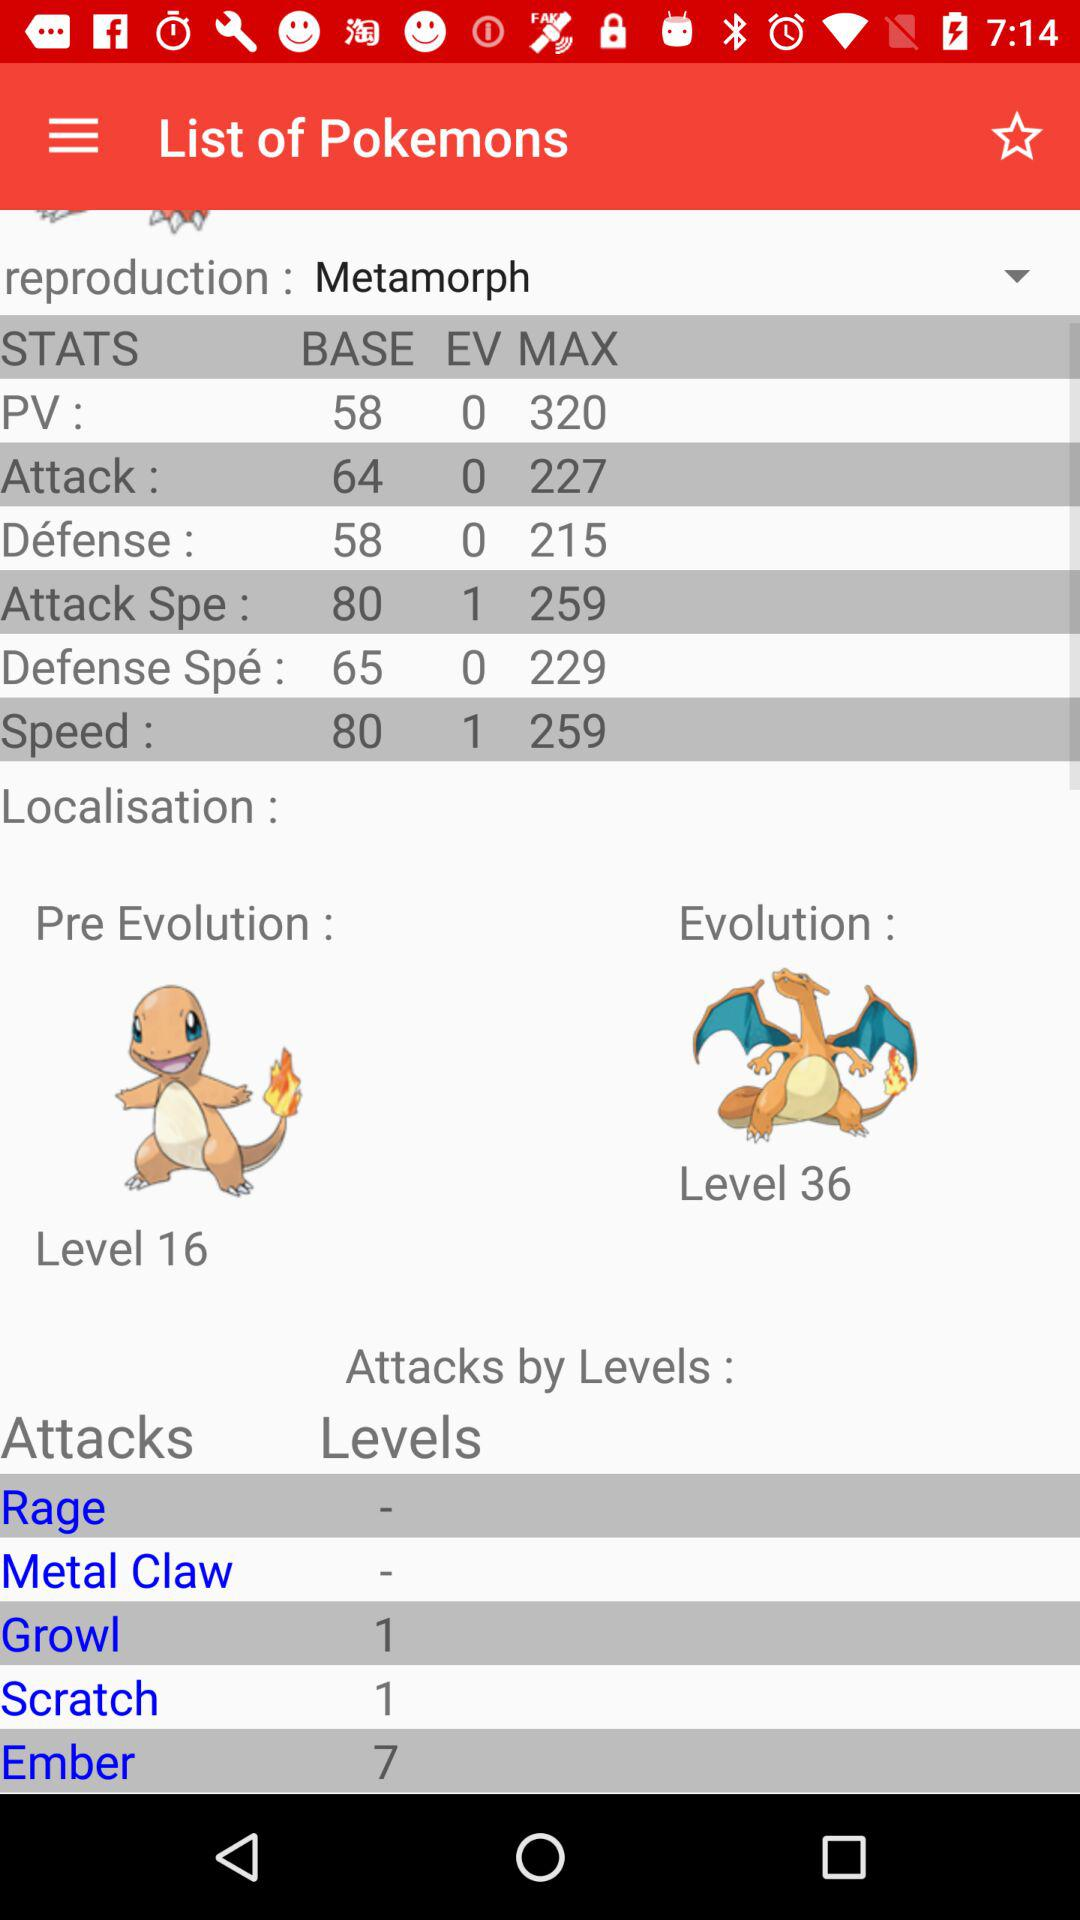What is the base value of PV? The base value of PV is 58. 